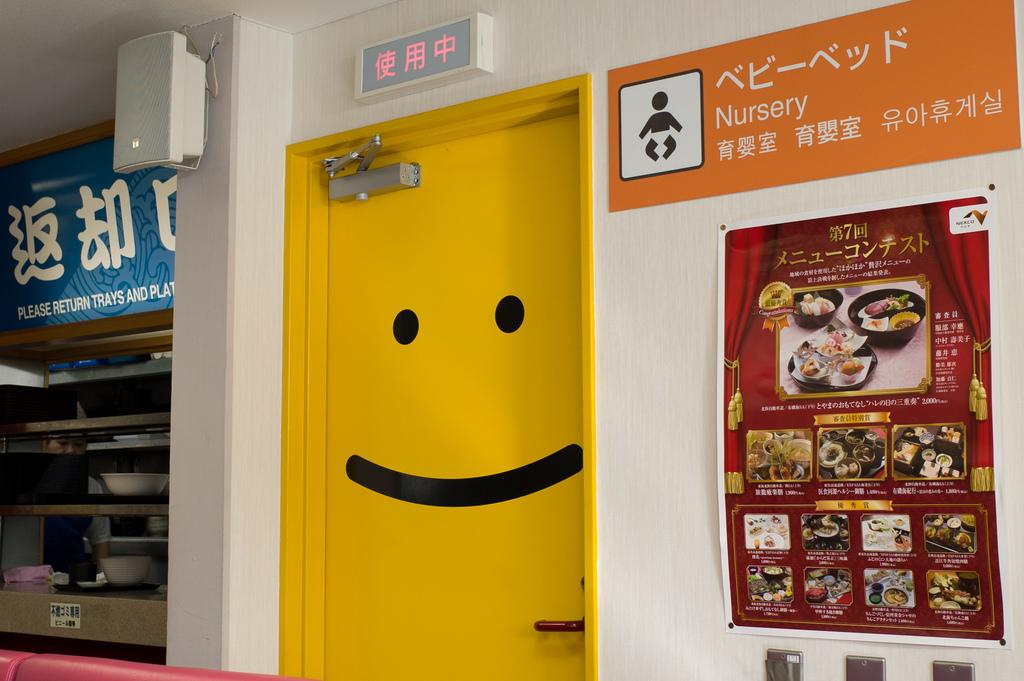<image>
Offer a succinct explanation of the picture presented. a room with a yellow door that has a sign that says 'nursery' on it 